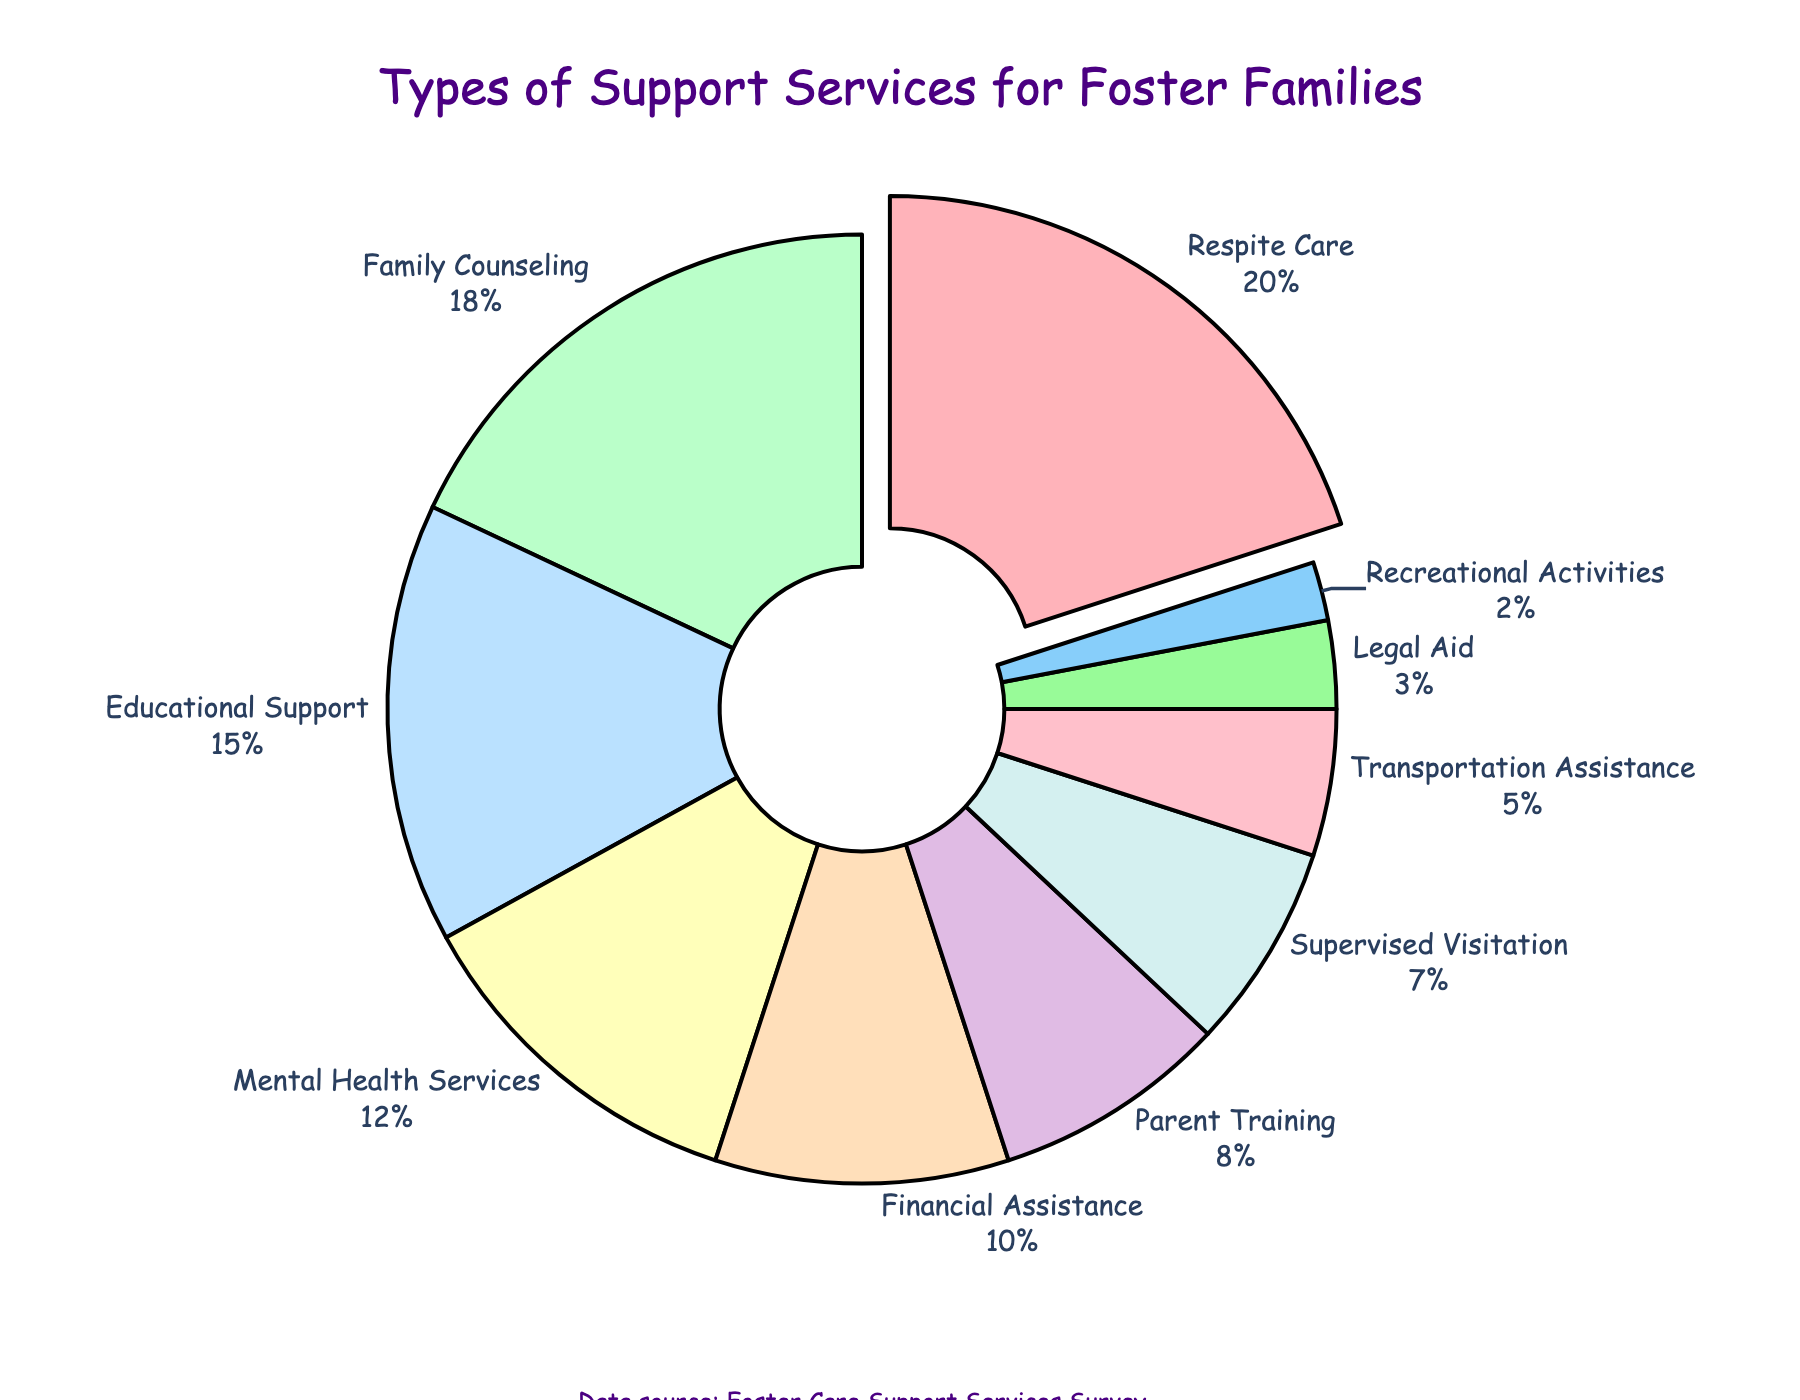Which service type provides the highest percentage of support for foster families? Look at the section of the pie chart that is pulled out from the rest and labeled with the highest percentage.
Answer: Respite Care What percentage of support services is provided by Family Counseling? Find the segment labeled "Family Counseling" on the pie chart and read its associated percentage.
Answer: 18% How much more percentage does Educational Support provide compared to Recreational Activities? Identify the percentages for Educational Support (15%) and Recreational Activities (2%), then subtract the second percentage from the first.
Answer: 13% Which support service provides the least percentage of support? Find the smallest segment in the pie chart and read its label.
Answer: Recreational Activities Does Mental Health Services provide more support than Financial Assistance? Compare the percentages of the segments labeled "Mental Health Services" (12%) and "Financial Assistance" (10%).
Answer: Yes What is the combined percentage of Respite Care, Family Counseling, and Educational Support? Add the percentages for Respite Care (20%), Family Counseling (18%), and Educational Support (15%).
Answer: 53% Which support service is represented by the light blue color? Identify the segment colored light blue on the pie chart and read its label.
Answer: Educational Support How much percentage is provided by support services that offer less than 10% each? Add percentages for services: Parent Training (8%), Supervised Visitation (7%), Transportation Assistance (5%), Legal Aid (3%), and Recreational Activities (2%).
Answer: 25% Is the percentage of support from Legal Aid greater than that of Recreational Activities? Compare the percentages of the segments labeled "Legal Aid" (3%) and "Recreational Activities" (2%).
Answer: Yes Which segment is the second largest on the pie chart? Look at the second largest segment after identifying the largest, and read its label.
Answer: Family Counseling 